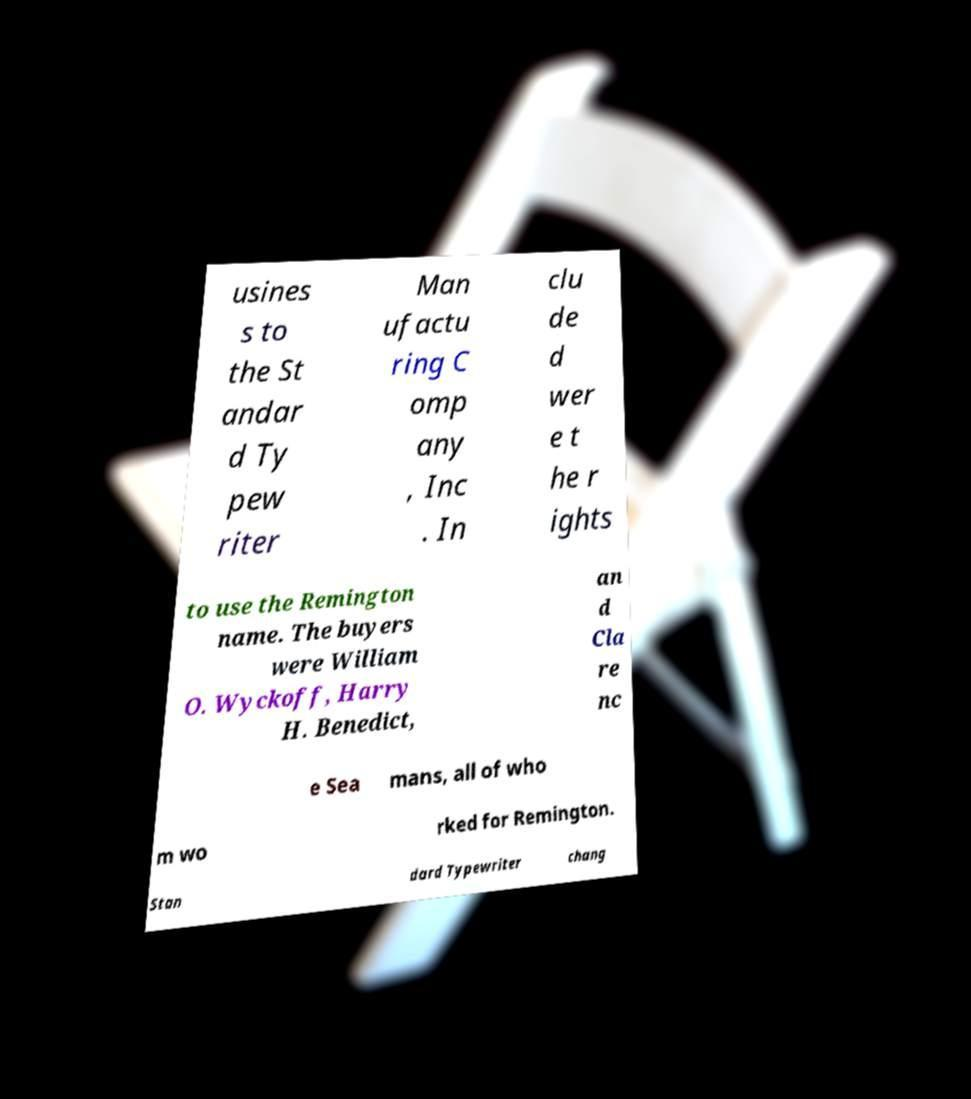Could you extract and type out the text from this image? usines s to the St andar d Ty pew riter Man ufactu ring C omp any , Inc . In clu de d wer e t he r ights to use the Remington name. The buyers were William O. Wyckoff, Harry H. Benedict, an d Cla re nc e Sea mans, all of who m wo rked for Remington. Stan dard Typewriter chang 